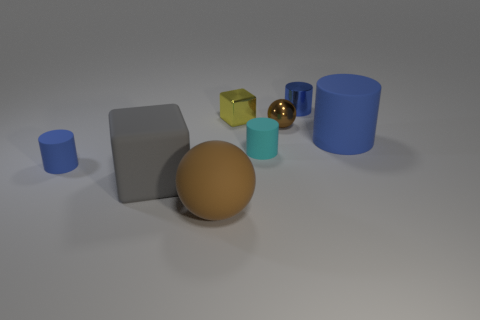What is the size of the matte object that is both in front of the tiny blue rubber object and behind the rubber sphere?
Keep it short and to the point. Large. Is the number of tiny yellow shiny objects that are to the right of the cyan object greater than the number of brown shiny things behind the big cube?
Keep it short and to the point. No. The big object that is the same shape as the tiny brown shiny object is what color?
Ensure brevity in your answer.  Brown. Do the sphere in front of the large gray matte block and the matte block have the same color?
Your answer should be very brief. No. How many large blue matte things are there?
Offer a terse response. 1. Are the tiny blue object that is in front of the small shiny cylinder and the yellow thing made of the same material?
Offer a very short reply. No. Is there any other thing that is the same material as the tiny cyan thing?
Keep it short and to the point. Yes. How many small things are to the right of the large gray object in front of the small cylinder that is in front of the cyan rubber thing?
Ensure brevity in your answer.  4. What size is the yellow metal cube?
Give a very brief answer. Small. Is the big ball the same color as the shiny cylinder?
Ensure brevity in your answer.  No. 